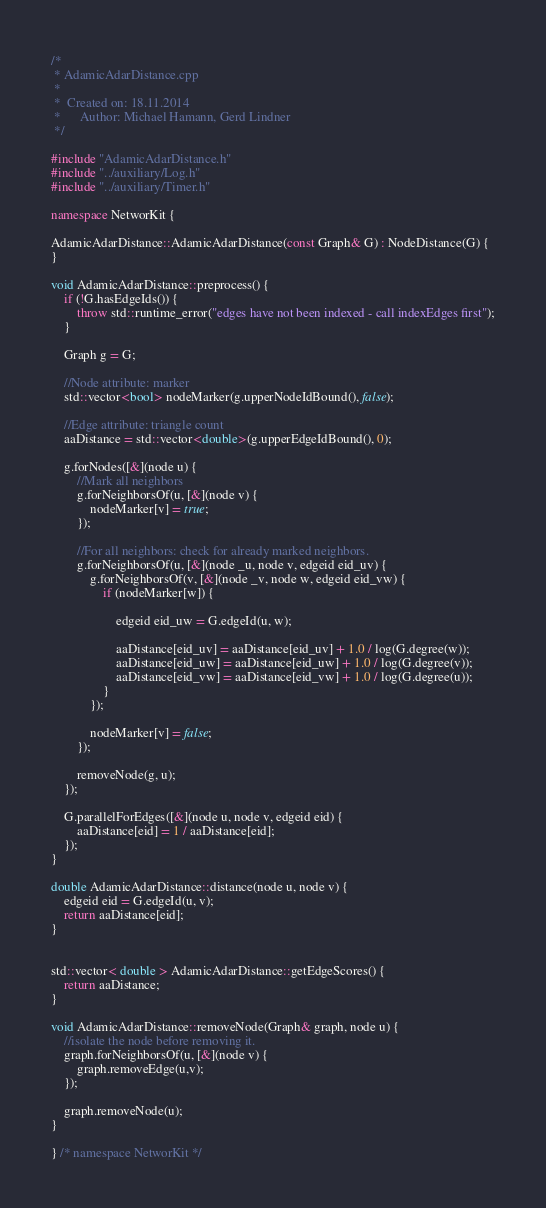<code> <loc_0><loc_0><loc_500><loc_500><_C++_>/*
 * AdamicAdarDistance.cpp
 *
 *  Created on: 18.11.2014
 *      Author: Michael Hamann, Gerd Lindner
 */

#include "AdamicAdarDistance.h"
#include "../auxiliary/Log.h"
#include "../auxiliary/Timer.h"

namespace NetworKit {

AdamicAdarDistance::AdamicAdarDistance(const Graph& G) : NodeDistance(G) {
}

void AdamicAdarDistance::preprocess() {
	if (!G.hasEdgeIds()) {
		throw std::runtime_error("edges have not been indexed - call indexEdges first");
	}

	Graph g = G;

	//Node attribute: marker
	std::vector<bool> nodeMarker(g.upperNodeIdBound(), false);

	//Edge attribute: triangle count
	aaDistance = std::vector<double>(g.upperEdgeIdBound(), 0);

	g.forNodes([&](node u) {
		//Mark all neighbors
		g.forNeighborsOf(u, [&](node v) {
			nodeMarker[v] = true;
		});

		//For all neighbors: check for already marked neighbors.
		g.forNeighborsOf(u, [&](node _u, node v, edgeid eid_uv) {
			g.forNeighborsOf(v, [&](node _v, node w, edgeid eid_vw) {
				if (nodeMarker[w]) {

					edgeid eid_uw = G.edgeId(u, w);

					aaDistance[eid_uv] = aaDistance[eid_uv] + 1.0 / log(G.degree(w));
					aaDistance[eid_uw] = aaDistance[eid_uw] + 1.0 / log(G.degree(v));
					aaDistance[eid_vw] = aaDistance[eid_vw] + 1.0 / log(G.degree(u));
				}
			});

			nodeMarker[v] = false;
		});

		removeNode(g, u);
	});

	G.parallelForEdges([&](node u, node v, edgeid eid) {
		aaDistance[eid] = 1 / aaDistance[eid];
	});
}

double AdamicAdarDistance::distance(node u, node v) {
	edgeid eid = G.edgeId(u, v);
	return aaDistance[eid];
}


std::vector< double > AdamicAdarDistance::getEdgeScores() {
	return aaDistance;
}

void AdamicAdarDistance::removeNode(Graph& graph, node u) {
	//isolate the node before removing it.
	graph.forNeighborsOf(u, [&](node v) {
		graph.removeEdge(u,v);
	});

	graph.removeNode(u);
}

} /* namespace NetworKit */
</code> 